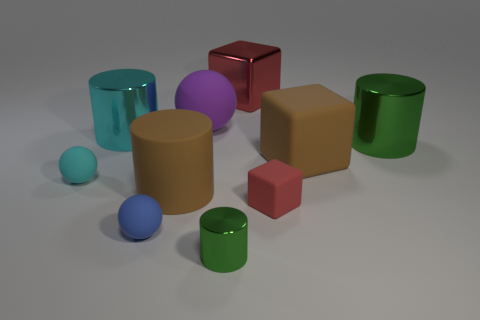Subtract all small green cylinders. How many cylinders are left? 3 Subtract all gray cylinders. How many red cubes are left? 2 Subtract all brown cylinders. How many cylinders are left? 3 Subtract all cubes. How many objects are left? 7 Subtract 1 spheres. How many spheres are left? 2 Subtract all red cylinders. Subtract all cyan blocks. How many cylinders are left? 4 Subtract all big shiny objects. Subtract all small blue rubber things. How many objects are left? 6 Add 2 large cylinders. How many large cylinders are left? 5 Add 4 metal blocks. How many metal blocks exist? 5 Subtract 1 brown cylinders. How many objects are left? 9 